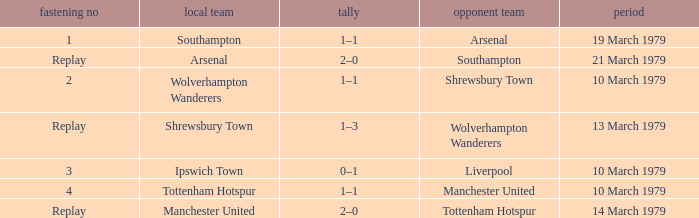Which tie number had an away team of Arsenal? 1.0. 